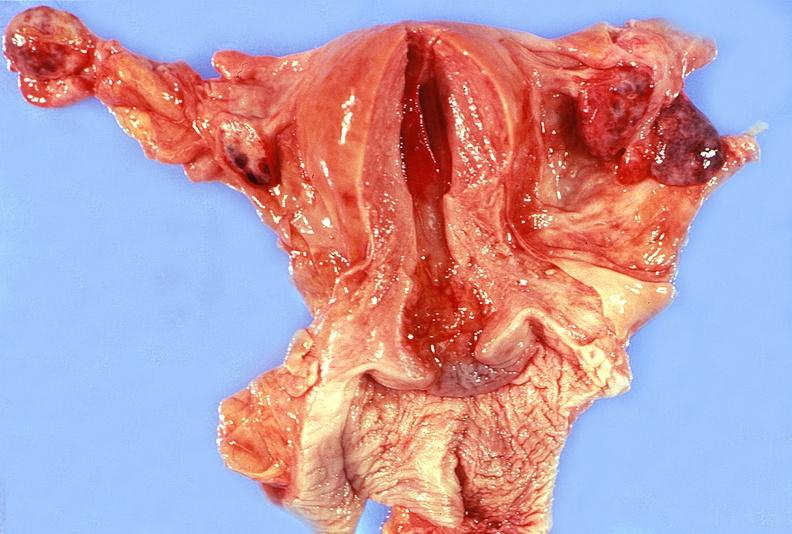does this image show uterus, fallopian tubes, ovaries ; normal?
Answer the question using a single word or phrase. Yes 